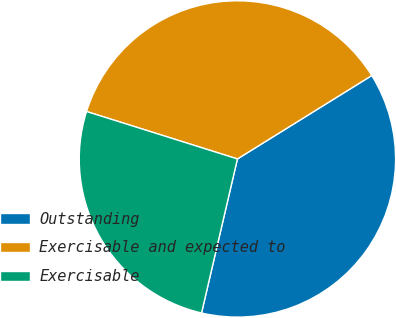Convert chart to OTSL. <chart><loc_0><loc_0><loc_500><loc_500><pie_chart><fcel>Outstanding<fcel>Exercisable and expected to<fcel>Exercisable<nl><fcel>37.49%<fcel>36.31%<fcel>26.21%<nl></chart> 